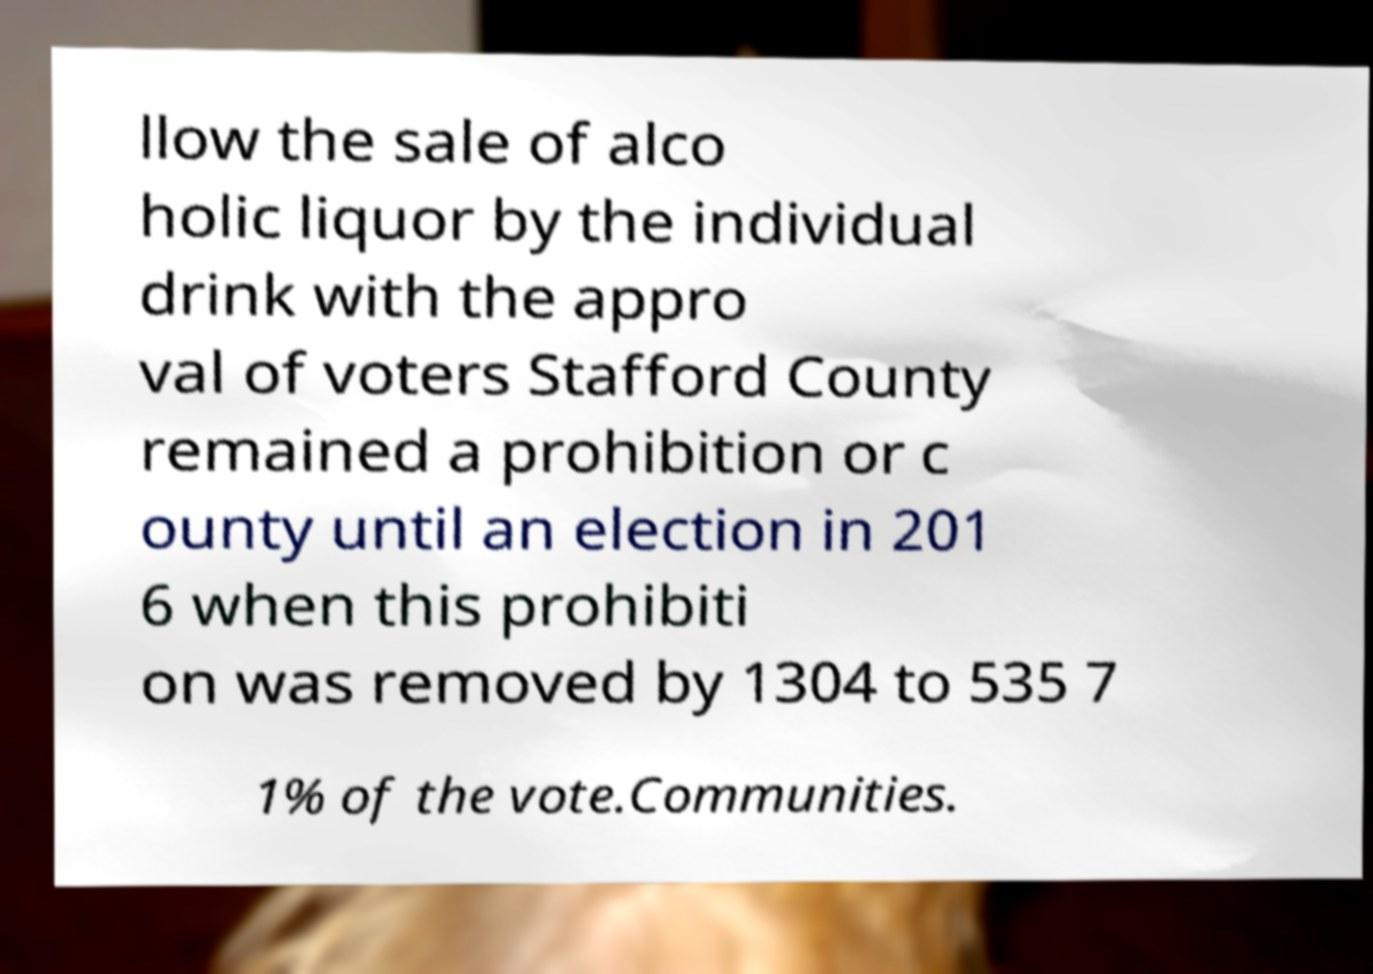Can you accurately transcribe the text from the provided image for me? llow the sale of alco holic liquor by the individual drink with the appro val of voters Stafford County remained a prohibition or c ounty until an election in 201 6 when this prohibiti on was removed by 1304 to 535 7 1% of the vote.Communities. 